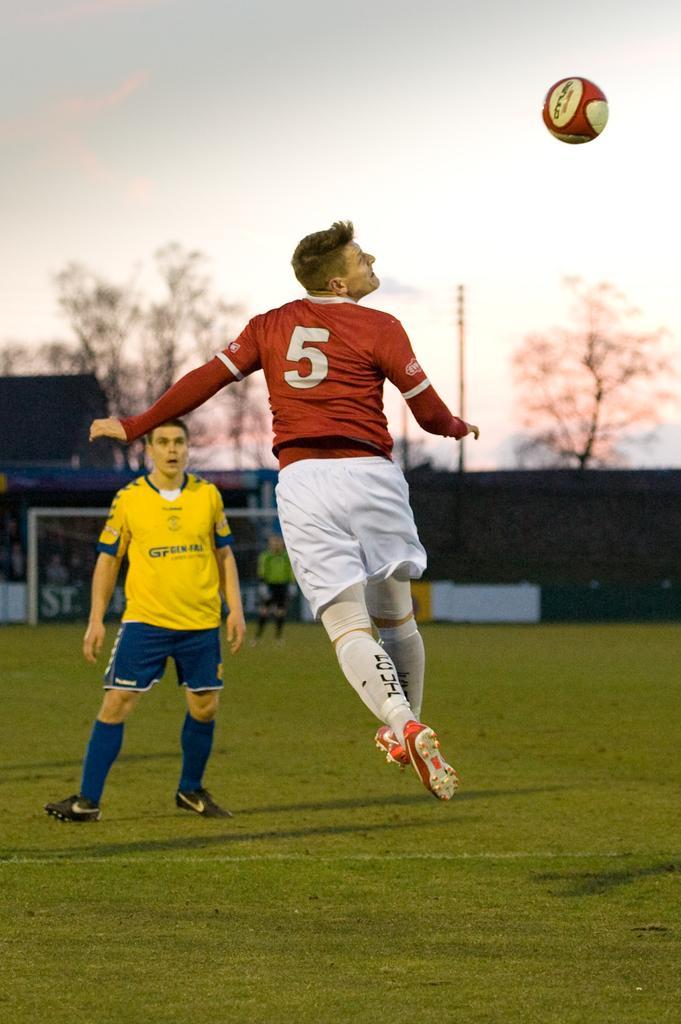In one or two sentences, can you explain what this image depicts? The person wearing red dress is in the air and there is a ball in front of him and the person wearing yellow dress is standing on a greenery ground and there are trees in the background. 